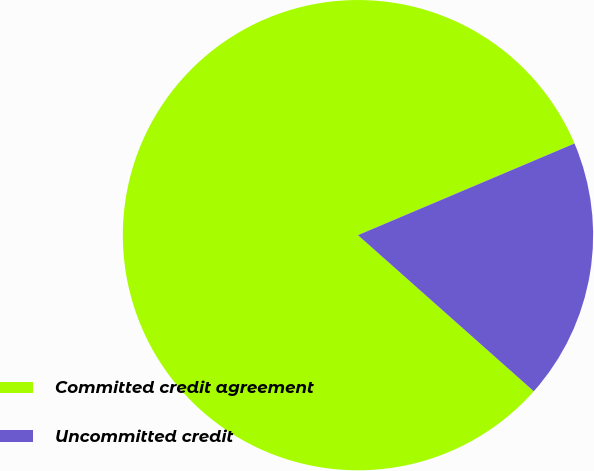Convert chart to OTSL. <chart><loc_0><loc_0><loc_500><loc_500><pie_chart><fcel>Committed credit agreement<fcel>Uncommitted credit<nl><fcel>82.07%<fcel>17.93%<nl></chart> 